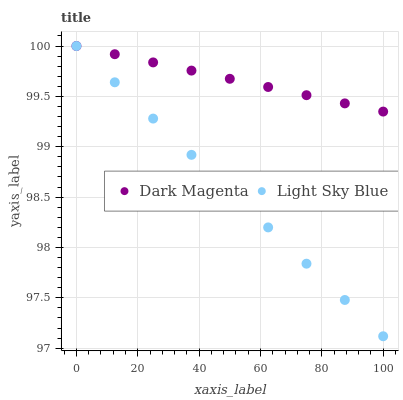Does Light Sky Blue have the minimum area under the curve?
Answer yes or no. Yes. Does Dark Magenta have the maximum area under the curve?
Answer yes or no. Yes. Does Dark Magenta have the minimum area under the curve?
Answer yes or no. No. Is Light Sky Blue the smoothest?
Answer yes or no. Yes. Is Dark Magenta the roughest?
Answer yes or no. Yes. Is Dark Magenta the smoothest?
Answer yes or no. No. Does Light Sky Blue have the lowest value?
Answer yes or no. Yes. Does Dark Magenta have the lowest value?
Answer yes or no. No. Does Dark Magenta have the highest value?
Answer yes or no. Yes. Does Dark Magenta intersect Light Sky Blue?
Answer yes or no. Yes. Is Dark Magenta less than Light Sky Blue?
Answer yes or no. No. Is Dark Magenta greater than Light Sky Blue?
Answer yes or no. No. 